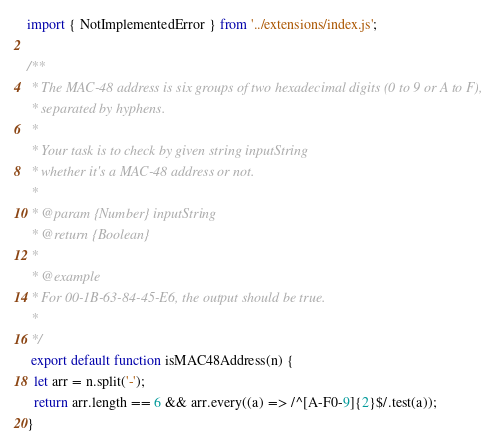Convert code to text. <code><loc_0><loc_0><loc_500><loc_500><_JavaScript_>import { NotImplementedError } from '../extensions/index.js';

/**
 * The MAC-48 address is six groups of two hexadecimal digits (0 to 9 or A to F),
 * separated by hyphens.
 *
 * Your task is to check by given string inputString
 * whether it's a MAC-48 address or not.
 *
 * @param {Number} inputString
 * @return {Boolean}
 *
 * @example
 * For 00-1B-63-84-45-E6, the output should be true.
 *
 */
 export default function isMAC48Address(n) {
  let arr = n.split('-');
  return arr.length == 6 && arr.every((a) => /^[A-F0-9]{2}$/.test(a));
} 
</code> 